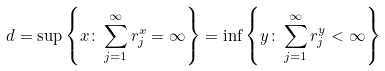Convert formula to latex. <formula><loc_0><loc_0><loc_500><loc_500>d = \sup \left \{ x \colon \sum _ { j = 1 } ^ { \infty } r _ { j } ^ { x } = \infty \right \} = \inf \left \{ y \colon \sum _ { j = 1 } ^ { \infty } r _ { j } ^ { y } < \infty \right \}</formula> 